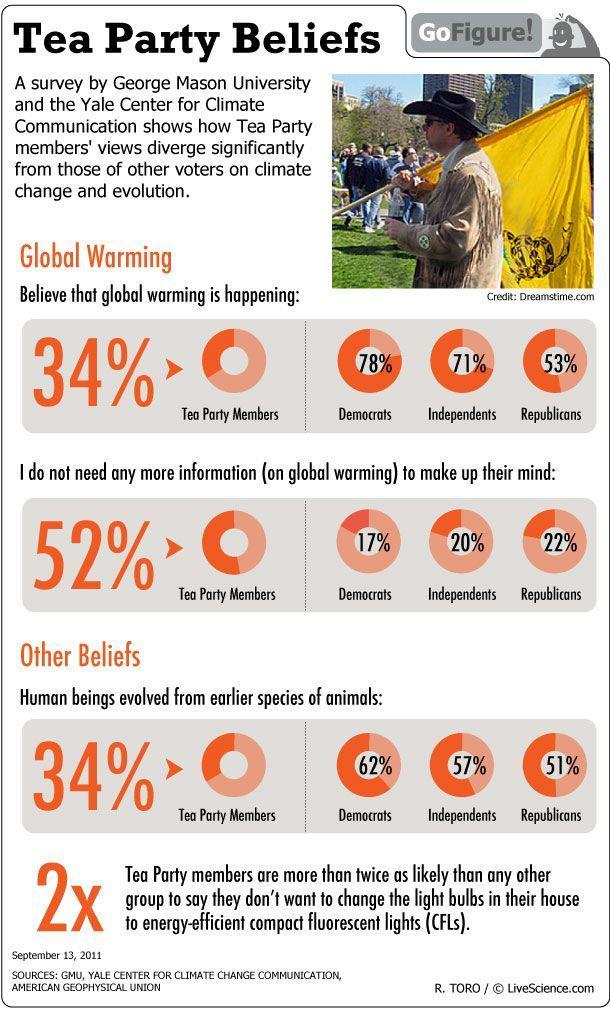Above 50% from which group of people feel they don't need more information on global warming?
Answer the question with a short phrase. Tea Party members What percent of Republicans believe that global warming is happening? 53% 